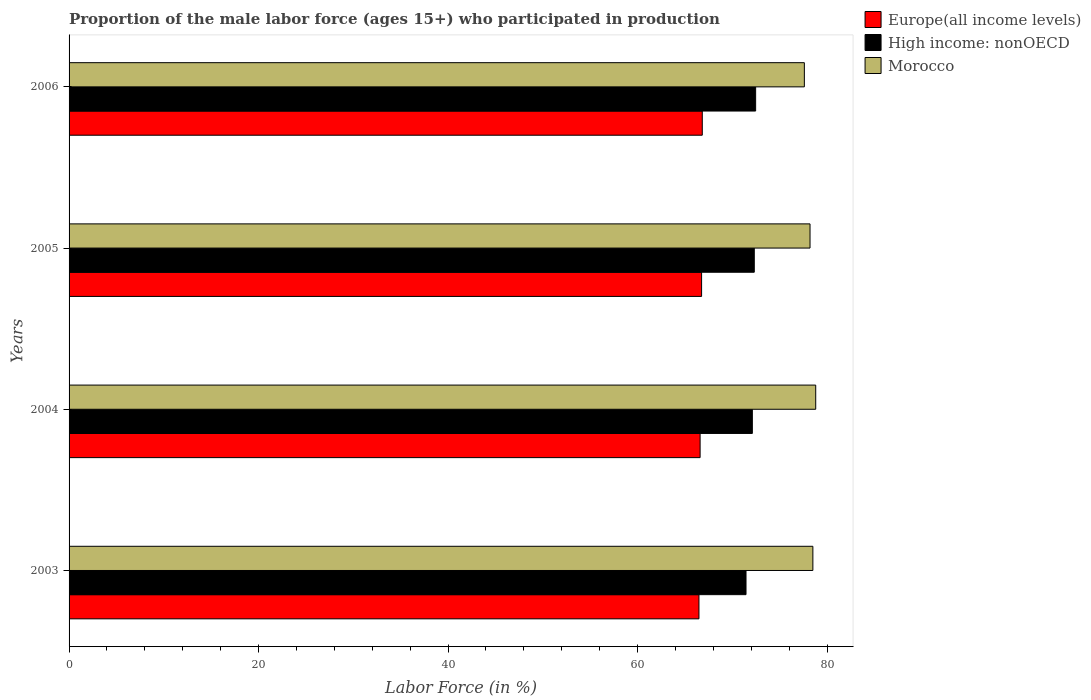Are the number of bars on each tick of the Y-axis equal?
Offer a terse response. Yes. What is the proportion of the male labor force who participated in production in Europe(all income levels) in 2006?
Offer a terse response. 66.83. Across all years, what is the maximum proportion of the male labor force who participated in production in Morocco?
Ensure brevity in your answer.  78.8. Across all years, what is the minimum proportion of the male labor force who participated in production in Morocco?
Ensure brevity in your answer.  77.6. What is the total proportion of the male labor force who participated in production in Morocco in the graph?
Your answer should be very brief. 313.1. What is the difference between the proportion of the male labor force who participated in production in Morocco in 2004 and that in 2005?
Your answer should be compact. 0.6. What is the difference between the proportion of the male labor force who participated in production in Europe(all income levels) in 2006 and the proportion of the male labor force who participated in production in High income: nonOECD in 2005?
Your answer should be compact. -5.49. What is the average proportion of the male labor force who participated in production in Morocco per year?
Your answer should be very brief. 78.27. In the year 2006, what is the difference between the proportion of the male labor force who participated in production in Morocco and proportion of the male labor force who participated in production in Europe(all income levels)?
Ensure brevity in your answer.  10.77. What is the ratio of the proportion of the male labor force who participated in production in Morocco in 2003 to that in 2004?
Provide a short and direct response. 1. Is the proportion of the male labor force who participated in production in Morocco in 2003 less than that in 2006?
Keep it short and to the point. No. Is the difference between the proportion of the male labor force who participated in production in Morocco in 2005 and 2006 greater than the difference between the proportion of the male labor force who participated in production in Europe(all income levels) in 2005 and 2006?
Provide a succinct answer. Yes. What is the difference between the highest and the second highest proportion of the male labor force who participated in production in Morocco?
Give a very brief answer. 0.3. What is the difference between the highest and the lowest proportion of the male labor force who participated in production in Morocco?
Ensure brevity in your answer.  1.2. Is the sum of the proportion of the male labor force who participated in production in High income: nonOECD in 2003 and 2004 greater than the maximum proportion of the male labor force who participated in production in Morocco across all years?
Give a very brief answer. Yes. What does the 2nd bar from the top in 2004 represents?
Your answer should be very brief. High income: nonOECD. What does the 1st bar from the bottom in 2005 represents?
Offer a terse response. Europe(all income levels). Are all the bars in the graph horizontal?
Ensure brevity in your answer.  Yes. Are the values on the major ticks of X-axis written in scientific E-notation?
Provide a short and direct response. No. Does the graph contain grids?
Your answer should be compact. No. Where does the legend appear in the graph?
Your answer should be very brief. Top right. How many legend labels are there?
Offer a very short reply. 3. What is the title of the graph?
Your response must be concise. Proportion of the male labor force (ages 15+) who participated in production. Does "French Polynesia" appear as one of the legend labels in the graph?
Give a very brief answer. No. What is the label or title of the Y-axis?
Offer a terse response. Years. What is the Labor Force (in %) in Europe(all income levels) in 2003?
Offer a terse response. 66.48. What is the Labor Force (in %) in High income: nonOECD in 2003?
Offer a very short reply. 71.44. What is the Labor Force (in %) of Morocco in 2003?
Keep it short and to the point. 78.5. What is the Labor Force (in %) in Europe(all income levels) in 2004?
Provide a short and direct response. 66.6. What is the Labor Force (in %) in High income: nonOECD in 2004?
Make the answer very short. 72.11. What is the Labor Force (in %) of Morocco in 2004?
Provide a succinct answer. 78.8. What is the Labor Force (in %) in Europe(all income levels) in 2005?
Ensure brevity in your answer.  66.76. What is the Labor Force (in %) in High income: nonOECD in 2005?
Provide a short and direct response. 72.32. What is the Labor Force (in %) in Morocco in 2005?
Your answer should be compact. 78.2. What is the Labor Force (in %) in Europe(all income levels) in 2006?
Provide a succinct answer. 66.83. What is the Labor Force (in %) in High income: nonOECD in 2006?
Offer a terse response. 72.46. What is the Labor Force (in %) in Morocco in 2006?
Ensure brevity in your answer.  77.6. Across all years, what is the maximum Labor Force (in %) in Europe(all income levels)?
Keep it short and to the point. 66.83. Across all years, what is the maximum Labor Force (in %) in High income: nonOECD?
Offer a terse response. 72.46. Across all years, what is the maximum Labor Force (in %) of Morocco?
Make the answer very short. 78.8. Across all years, what is the minimum Labor Force (in %) in Europe(all income levels)?
Your answer should be compact. 66.48. Across all years, what is the minimum Labor Force (in %) of High income: nonOECD?
Provide a short and direct response. 71.44. Across all years, what is the minimum Labor Force (in %) of Morocco?
Give a very brief answer. 77.6. What is the total Labor Force (in %) of Europe(all income levels) in the graph?
Make the answer very short. 266.66. What is the total Labor Force (in %) of High income: nonOECD in the graph?
Keep it short and to the point. 288.33. What is the total Labor Force (in %) in Morocco in the graph?
Provide a succinct answer. 313.1. What is the difference between the Labor Force (in %) in Europe(all income levels) in 2003 and that in 2004?
Give a very brief answer. -0.12. What is the difference between the Labor Force (in %) in High income: nonOECD in 2003 and that in 2004?
Provide a succinct answer. -0.67. What is the difference between the Labor Force (in %) of Morocco in 2003 and that in 2004?
Keep it short and to the point. -0.3. What is the difference between the Labor Force (in %) in Europe(all income levels) in 2003 and that in 2005?
Your answer should be very brief. -0.28. What is the difference between the Labor Force (in %) in High income: nonOECD in 2003 and that in 2005?
Offer a terse response. -0.87. What is the difference between the Labor Force (in %) of Europe(all income levels) in 2003 and that in 2006?
Provide a succinct answer. -0.35. What is the difference between the Labor Force (in %) of High income: nonOECD in 2003 and that in 2006?
Give a very brief answer. -1.02. What is the difference between the Labor Force (in %) in Morocco in 2003 and that in 2006?
Your answer should be very brief. 0.9. What is the difference between the Labor Force (in %) of Europe(all income levels) in 2004 and that in 2005?
Your answer should be compact. -0.16. What is the difference between the Labor Force (in %) of High income: nonOECD in 2004 and that in 2005?
Offer a very short reply. -0.2. What is the difference between the Labor Force (in %) of Morocco in 2004 and that in 2005?
Your answer should be compact. 0.6. What is the difference between the Labor Force (in %) in Europe(all income levels) in 2004 and that in 2006?
Make the answer very short. -0.23. What is the difference between the Labor Force (in %) of High income: nonOECD in 2004 and that in 2006?
Give a very brief answer. -0.35. What is the difference between the Labor Force (in %) in Morocco in 2004 and that in 2006?
Offer a terse response. 1.2. What is the difference between the Labor Force (in %) of Europe(all income levels) in 2005 and that in 2006?
Ensure brevity in your answer.  -0.07. What is the difference between the Labor Force (in %) of High income: nonOECD in 2005 and that in 2006?
Make the answer very short. -0.14. What is the difference between the Labor Force (in %) in Morocco in 2005 and that in 2006?
Provide a short and direct response. 0.6. What is the difference between the Labor Force (in %) of Europe(all income levels) in 2003 and the Labor Force (in %) of High income: nonOECD in 2004?
Provide a succinct answer. -5.64. What is the difference between the Labor Force (in %) in Europe(all income levels) in 2003 and the Labor Force (in %) in Morocco in 2004?
Your response must be concise. -12.32. What is the difference between the Labor Force (in %) of High income: nonOECD in 2003 and the Labor Force (in %) of Morocco in 2004?
Give a very brief answer. -7.36. What is the difference between the Labor Force (in %) of Europe(all income levels) in 2003 and the Labor Force (in %) of High income: nonOECD in 2005?
Ensure brevity in your answer.  -5.84. What is the difference between the Labor Force (in %) of Europe(all income levels) in 2003 and the Labor Force (in %) of Morocco in 2005?
Ensure brevity in your answer.  -11.72. What is the difference between the Labor Force (in %) in High income: nonOECD in 2003 and the Labor Force (in %) in Morocco in 2005?
Your answer should be compact. -6.76. What is the difference between the Labor Force (in %) of Europe(all income levels) in 2003 and the Labor Force (in %) of High income: nonOECD in 2006?
Keep it short and to the point. -5.98. What is the difference between the Labor Force (in %) in Europe(all income levels) in 2003 and the Labor Force (in %) in Morocco in 2006?
Make the answer very short. -11.12. What is the difference between the Labor Force (in %) of High income: nonOECD in 2003 and the Labor Force (in %) of Morocco in 2006?
Give a very brief answer. -6.16. What is the difference between the Labor Force (in %) in Europe(all income levels) in 2004 and the Labor Force (in %) in High income: nonOECD in 2005?
Make the answer very short. -5.72. What is the difference between the Labor Force (in %) of Europe(all income levels) in 2004 and the Labor Force (in %) of Morocco in 2005?
Provide a succinct answer. -11.6. What is the difference between the Labor Force (in %) in High income: nonOECD in 2004 and the Labor Force (in %) in Morocco in 2005?
Provide a short and direct response. -6.09. What is the difference between the Labor Force (in %) in Europe(all income levels) in 2004 and the Labor Force (in %) in High income: nonOECD in 2006?
Provide a succinct answer. -5.86. What is the difference between the Labor Force (in %) in Europe(all income levels) in 2004 and the Labor Force (in %) in Morocco in 2006?
Make the answer very short. -11. What is the difference between the Labor Force (in %) in High income: nonOECD in 2004 and the Labor Force (in %) in Morocco in 2006?
Ensure brevity in your answer.  -5.49. What is the difference between the Labor Force (in %) of Europe(all income levels) in 2005 and the Labor Force (in %) of High income: nonOECD in 2006?
Ensure brevity in your answer.  -5.7. What is the difference between the Labor Force (in %) of Europe(all income levels) in 2005 and the Labor Force (in %) of Morocco in 2006?
Provide a short and direct response. -10.84. What is the difference between the Labor Force (in %) of High income: nonOECD in 2005 and the Labor Force (in %) of Morocco in 2006?
Provide a short and direct response. -5.28. What is the average Labor Force (in %) in Europe(all income levels) per year?
Your response must be concise. 66.66. What is the average Labor Force (in %) of High income: nonOECD per year?
Offer a terse response. 72.08. What is the average Labor Force (in %) of Morocco per year?
Your answer should be compact. 78.28. In the year 2003, what is the difference between the Labor Force (in %) in Europe(all income levels) and Labor Force (in %) in High income: nonOECD?
Give a very brief answer. -4.97. In the year 2003, what is the difference between the Labor Force (in %) in Europe(all income levels) and Labor Force (in %) in Morocco?
Offer a very short reply. -12.02. In the year 2003, what is the difference between the Labor Force (in %) in High income: nonOECD and Labor Force (in %) in Morocco?
Make the answer very short. -7.06. In the year 2004, what is the difference between the Labor Force (in %) of Europe(all income levels) and Labor Force (in %) of High income: nonOECD?
Offer a terse response. -5.51. In the year 2004, what is the difference between the Labor Force (in %) of Europe(all income levels) and Labor Force (in %) of Morocco?
Your answer should be compact. -12.2. In the year 2004, what is the difference between the Labor Force (in %) of High income: nonOECD and Labor Force (in %) of Morocco?
Offer a terse response. -6.69. In the year 2005, what is the difference between the Labor Force (in %) in Europe(all income levels) and Labor Force (in %) in High income: nonOECD?
Your answer should be very brief. -5.56. In the year 2005, what is the difference between the Labor Force (in %) of Europe(all income levels) and Labor Force (in %) of Morocco?
Offer a very short reply. -11.44. In the year 2005, what is the difference between the Labor Force (in %) of High income: nonOECD and Labor Force (in %) of Morocco?
Offer a terse response. -5.88. In the year 2006, what is the difference between the Labor Force (in %) of Europe(all income levels) and Labor Force (in %) of High income: nonOECD?
Provide a succinct answer. -5.63. In the year 2006, what is the difference between the Labor Force (in %) in Europe(all income levels) and Labor Force (in %) in Morocco?
Your answer should be very brief. -10.77. In the year 2006, what is the difference between the Labor Force (in %) of High income: nonOECD and Labor Force (in %) of Morocco?
Your response must be concise. -5.14. What is the ratio of the Labor Force (in %) of High income: nonOECD in 2003 to that in 2004?
Your answer should be compact. 0.99. What is the ratio of the Labor Force (in %) of Morocco in 2003 to that in 2005?
Keep it short and to the point. 1. What is the ratio of the Labor Force (in %) in High income: nonOECD in 2003 to that in 2006?
Give a very brief answer. 0.99. What is the ratio of the Labor Force (in %) of Morocco in 2003 to that in 2006?
Provide a succinct answer. 1.01. What is the ratio of the Labor Force (in %) of Europe(all income levels) in 2004 to that in 2005?
Provide a short and direct response. 1. What is the ratio of the Labor Force (in %) in High income: nonOECD in 2004 to that in 2005?
Provide a short and direct response. 1. What is the ratio of the Labor Force (in %) of Morocco in 2004 to that in 2005?
Make the answer very short. 1.01. What is the ratio of the Labor Force (in %) in Europe(all income levels) in 2004 to that in 2006?
Offer a terse response. 1. What is the ratio of the Labor Force (in %) in Morocco in 2004 to that in 2006?
Ensure brevity in your answer.  1.02. What is the ratio of the Labor Force (in %) of Morocco in 2005 to that in 2006?
Keep it short and to the point. 1.01. What is the difference between the highest and the second highest Labor Force (in %) in Europe(all income levels)?
Your response must be concise. 0.07. What is the difference between the highest and the second highest Labor Force (in %) of High income: nonOECD?
Offer a terse response. 0.14. What is the difference between the highest and the second highest Labor Force (in %) of Morocco?
Keep it short and to the point. 0.3. What is the difference between the highest and the lowest Labor Force (in %) of Europe(all income levels)?
Your answer should be very brief. 0.35. What is the difference between the highest and the lowest Labor Force (in %) of High income: nonOECD?
Your answer should be very brief. 1.02. 